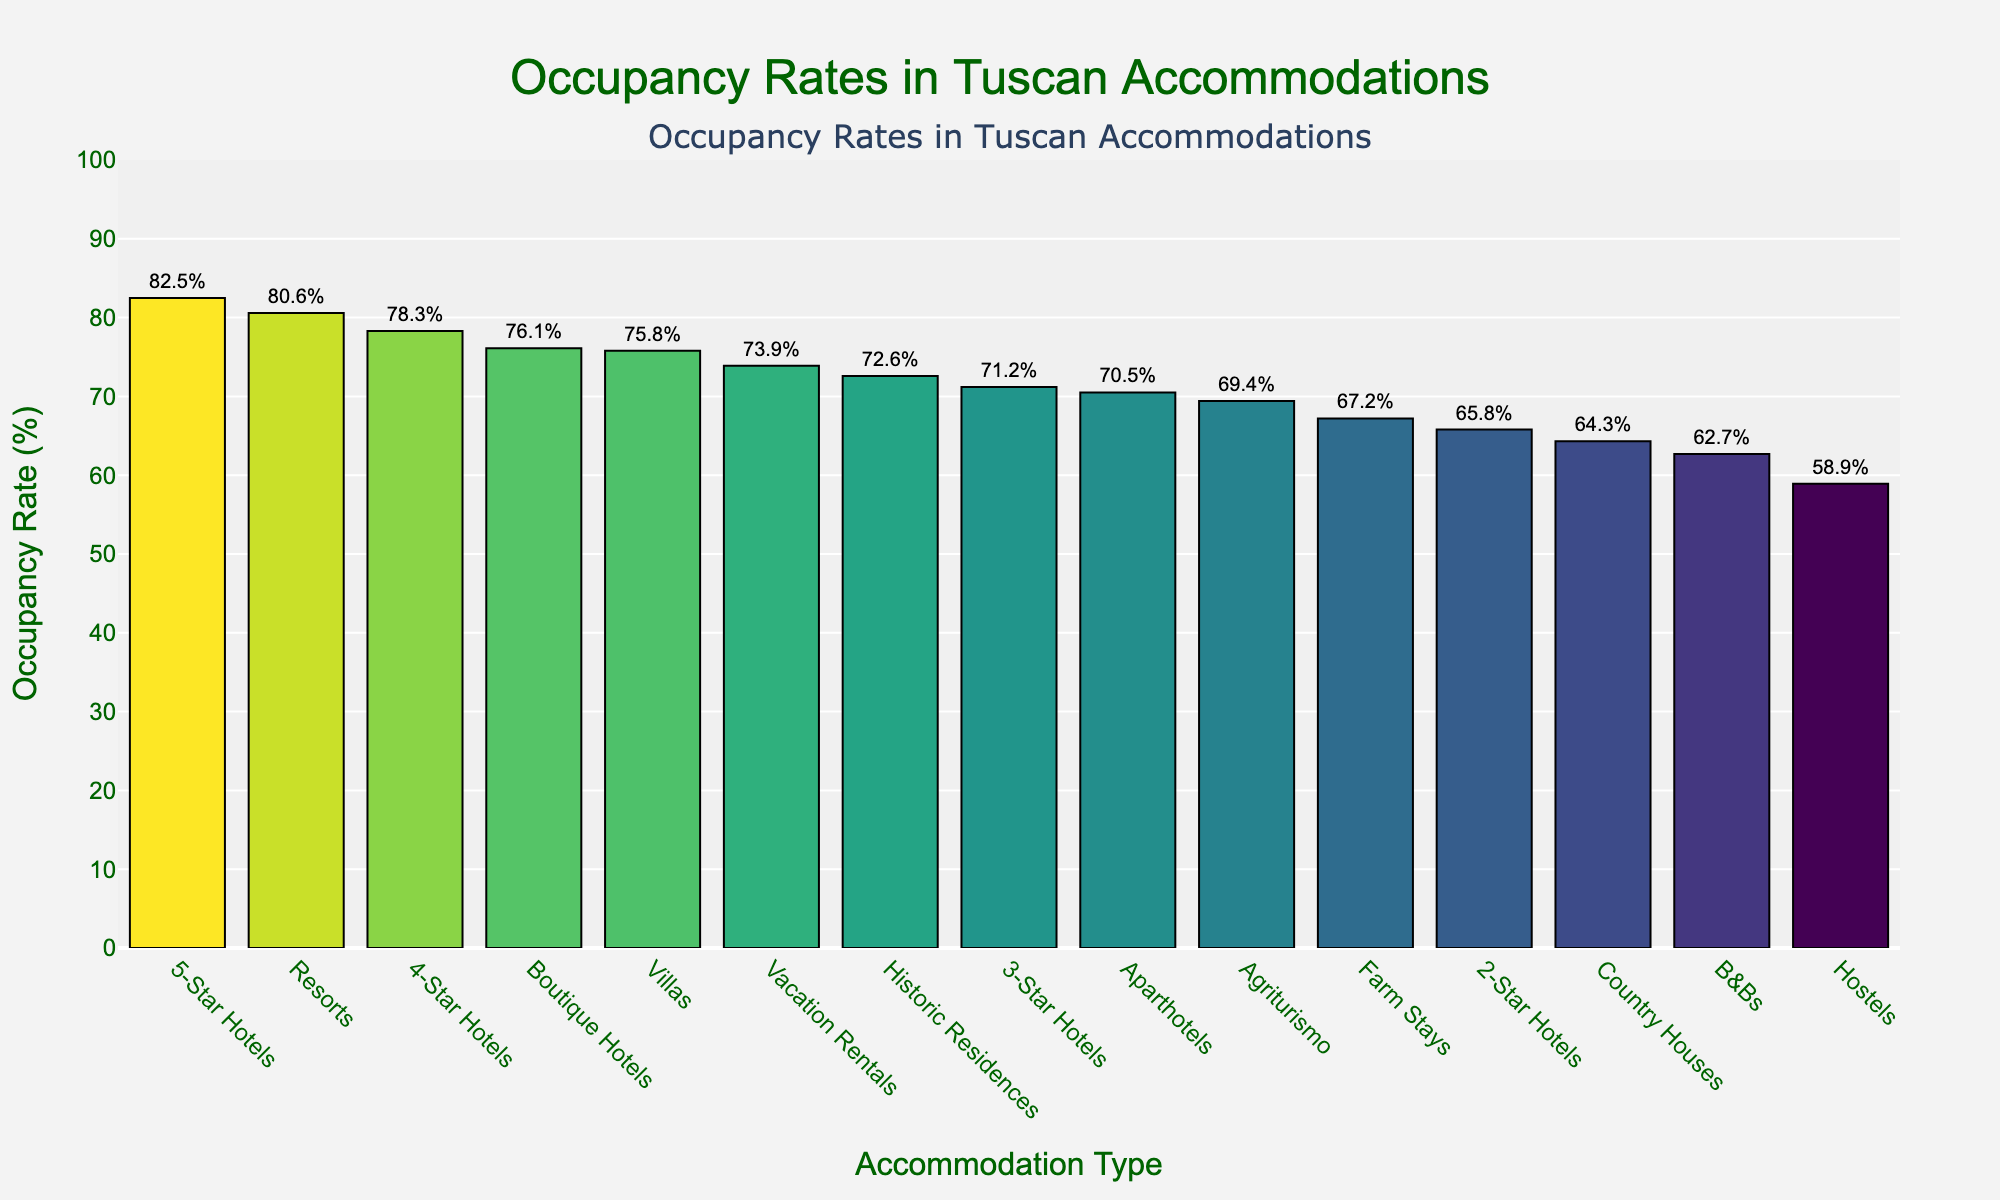Which type of accommodation has the highest occupancy rate? The 5-Star Hotels bar is the tallest, indicating the highest occupancy rate.
Answer: 5-Star Hotels Which accommodation type has a lower occupancy rate, Boutique Hotels or Vacation Rentals? By comparing the heights of the bars, we see the Boutique Hotels bar is shorter than the Vacation Rentals bar.
Answer: Boutique Hotels What's the average occupancy rate of Hotels (all categories combined)? Sum the occupancy rates for 5-Star, 4-Star, 3-Star, 2-Star, and Boutique Hotels, then divide by the number of types: (82.5 + 78.3 + 71.2 + 65.8 + 76.1) / 5 = 74.78.
Answer: 74.8% Are Agriturismo more popular than B&Bs in terms of occupancy rate? Compare the heights of the Agriturismo and B&Bs bars. The Agriturismo bar is taller, indicating a higher occupancy rate.
Answer: Yes Which accommodation types have an occupancy rate greater than 75%? Identify the bars with occupancy rates above 75%: 5-Star Hotels, 4-Star Hotels, Resorts, Villas.
Answer: 5-Star Hotels, 4-Star Hotels, Resorts, Villas What is the difference in occupancy rate between Aparthotels and Farm Stays? Subtract the occupancy rate of Farm Stays from Aparthotels: 70.5 - 67.2 = 3.3%.
Answer: 3.3% Which has a higher occupancy rate, Historic Residences or 3-Star Hotels? The bars for Historic Residences and 3-Star Hotels are compared, the Historic Residences bar is taller.
Answer: Historic Residences How does the occupancy rate of Country Houses compare to that of 2-Star Hotels? Both occupancy rates are visually compared; the Country Houses bar is shorter than the 2-Star Hotels bar.
Answer: Lower What is the combined occupancy rate of Hostels and Farm Stays? Add the occupancy rates of Hostels and Farm Stays: 58.9 + 67.2 = 126.1.
Answer: 126.1% Which type of accommodation shows closer occupancy rates, Aparthotels and 3-Star Hotels, or Resorts and 5-Star Hotels? Calculate the differences: Aparthotels and 3-Star Hotels (70.5 – 71.2 = 0.7), Resorts and 5-Star Hotels (80.6 – 82.5 = 1.9). The difference for Aparthotels and 3-Star Hotels is smaller.
Answer: Aparthotels and 3-Star Hotels 